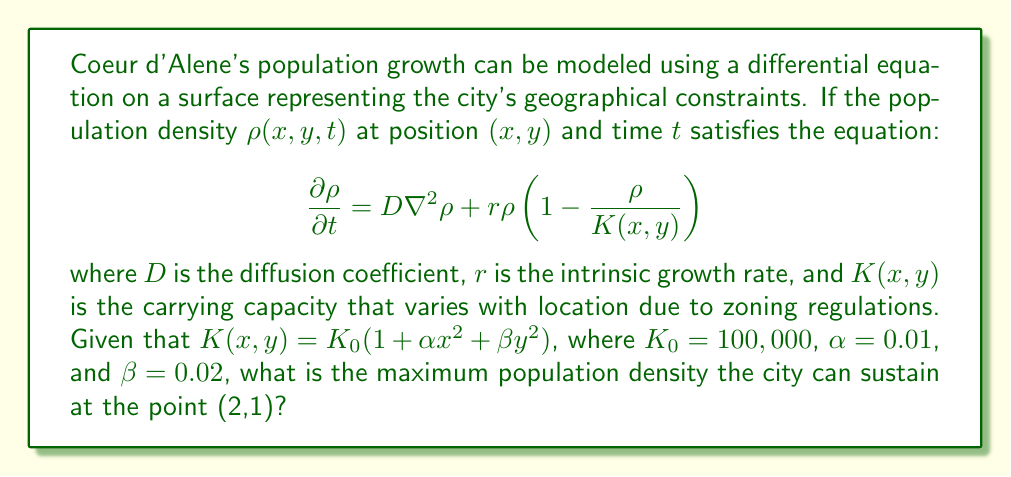Can you answer this question? To solve this problem, we need to follow these steps:

1) The equation given is a reaction-diffusion equation on a surface, where the reaction term follows logistic growth with a spatially varying carrying capacity.

2) The maximum population density at any point $(x,y)$ is given by the carrying capacity $K(x,y)$ at that point.

3) We are given that $K(x,y) = K_0(1+\alpha x^2+\beta y^2)$, where:
   $K_0 = 100,000$
   $\alpha = 0.01$
   $\beta = 0.02$

4) We need to calculate $K(2,1)$:

   $K(2,1) = K_0(1+\alpha(2)^2+\beta(1)^2)$
   
   $= 100,000(1+0.01(4)+0.02(1))$
   
   $= 100,000(1+0.04+0.02)$
   
   $= 100,000(1.06)$
   
   $= 106,000$

5) Therefore, the maximum population density at the point (2,1) is 106,000 people per unit area.
Answer: 106,000 people per unit area 